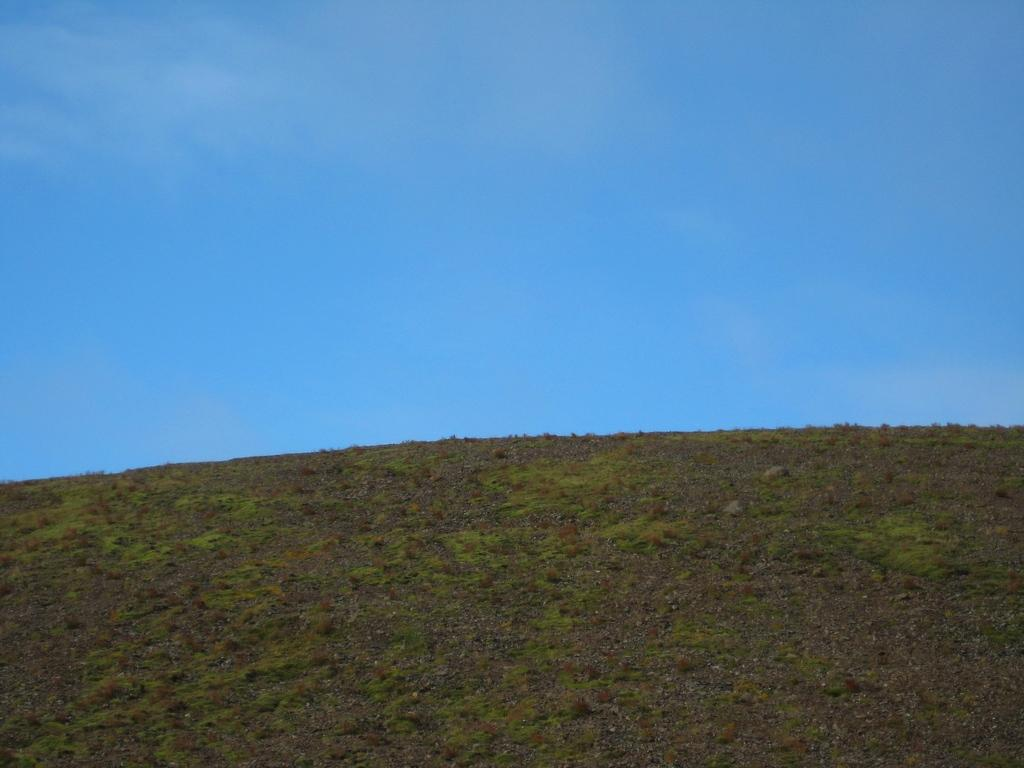What type of vegetation is present on the ground in the image? There is grass on the ground in the image. What part of the natural environment is visible in the background of the image? The sky is visible in the background of the image. What type of riddle is being solved by the finger in the image? There is no finger or riddle present in the image. 